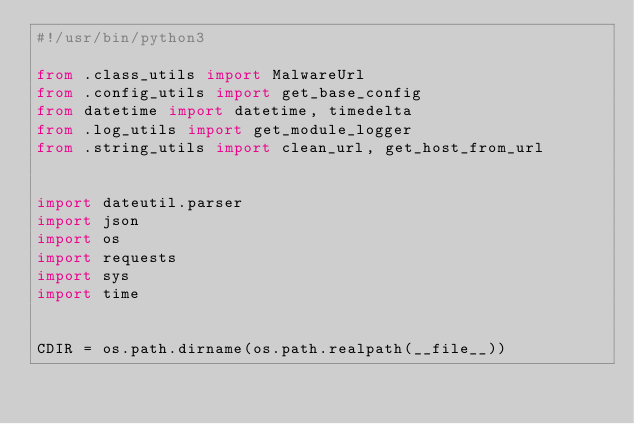Convert code to text. <code><loc_0><loc_0><loc_500><loc_500><_Python_>#!/usr/bin/python3

from .class_utils import MalwareUrl
from .config_utils import get_base_config
from datetime import datetime, timedelta
from .log_utils import get_module_logger
from .string_utils import clean_url, get_host_from_url


import dateutil.parser
import json
import os
import requests
import sys
import time


CDIR = os.path.dirname(os.path.realpath(__file__))</code> 